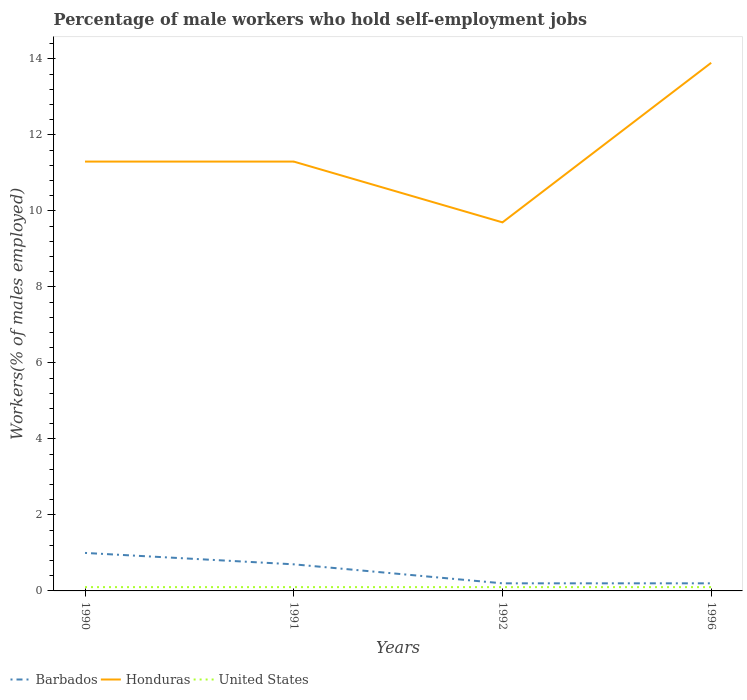How many different coloured lines are there?
Your response must be concise. 3. Does the line corresponding to Honduras intersect with the line corresponding to Barbados?
Provide a short and direct response. No. Is the number of lines equal to the number of legend labels?
Offer a very short reply. Yes. Across all years, what is the maximum percentage of self-employed male workers in United States?
Offer a very short reply. 0.1. In which year was the percentage of self-employed male workers in Honduras maximum?
Your response must be concise. 1992. What is the total percentage of self-employed male workers in Honduras in the graph?
Your response must be concise. -2.6. What is the difference between the highest and the second highest percentage of self-employed male workers in Barbados?
Provide a short and direct response. 0.8. Is the percentage of self-employed male workers in Honduras strictly greater than the percentage of self-employed male workers in United States over the years?
Make the answer very short. No. How many years are there in the graph?
Provide a short and direct response. 4. Does the graph contain grids?
Your answer should be compact. No. Where does the legend appear in the graph?
Give a very brief answer. Bottom left. How many legend labels are there?
Offer a terse response. 3. What is the title of the graph?
Ensure brevity in your answer.  Percentage of male workers who hold self-employment jobs. Does "Austria" appear as one of the legend labels in the graph?
Provide a short and direct response. No. What is the label or title of the Y-axis?
Offer a very short reply. Workers(% of males employed). What is the Workers(% of males employed) of Barbados in 1990?
Your answer should be very brief. 1. What is the Workers(% of males employed) in Honduras in 1990?
Keep it short and to the point. 11.3. What is the Workers(% of males employed) of United States in 1990?
Provide a short and direct response. 0.1. What is the Workers(% of males employed) of Barbados in 1991?
Offer a terse response. 0.7. What is the Workers(% of males employed) in Honduras in 1991?
Your answer should be very brief. 11.3. What is the Workers(% of males employed) of United States in 1991?
Your response must be concise. 0.1. What is the Workers(% of males employed) of Barbados in 1992?
Offer a very short reply. 0.2. What is the Workers(% of males employed) in Honduras in 1992?
Provide a short and direct response. 9.7. What is the Workers(% of males employed) in United States in 1992?
Offer a very short reply. 0.1. What is the Workers(% of males employed) in Barbados in 1996?
Provide a succinct answer. 0.2. What is the Workers(% of males employed) of Honduras in 1996?
Provide a short and direct response. 13.9. What is the Workers(% of males employed) of United States in 1996?
Keep it short and to the point. 0.1. Across all years, what is the maximum Workers(% of males employed) of Honduras?
Provide a succinct answer. 13.9. Across all years, what is the maximum Workers(% of males employed) of United States?
Your answer should be compact. 0.1. Across all years, what is the minimum Workers(% of males employed) in Barbados?
Offer a very short reply. 0.2. Across all years, what is the minimum Workers(% of males employed) of Honduras?
Your answer should be very brief. 9.7. Across all years, what is the minimum Workers(% of males employed) in United States?
Offer a terse response. 0.1. What is the total Workers(% of males employed) in Barbados in the graph?
Offer a very short reply. 2.1. What is the total Workers(% of males employed) in Honduras in the graph?
Your answer should be compact. 46.2. What is the total Workers(% of males employed) of United States in the graph?
Offer a very short reply. 0.4. What is the difference between the Workers(% of males employed) of Honduras in 1990 and that in 1992?
Keep it short and to the point. 1.6. What is the difference between the Workers(% of males employed) in United States in 1990 and that in 1992?
Offer a terse response. 0. What is the difference between the Workers(% of males employed) in Barbados in 1990 and that in 1996?
Give a very brief answer. 0.8. What is the difference between the Workers(% of males employed) of Honduras in 1990 and that in 1996?
Your response must be concise. -2.6. What is the difference between the Workers(% of males employed) in United States in 1990 and that in 1996?
Keep it short and to the point. 0. What is the difference between the Workers(% of males employed) of United States in 1991 and that in 1992?
Offer a terse response. 0. What is the difference between the Workers(% of males employed) of United States in 1991 and that in 1996?
Your answer should be very brief. 0. What is the difference between the Workers(% of males employed) in Honduras in 1992 and that in 1996?
Make the answer very short. -4.2. What is the difference between the Workers(% of males employed) of United States in 1992 and that in 1996?
Offer a terse response. 0. What is the difference between the Workers(% of males employed) of Barbados in 1990 and the Workers(% of males employed) of United States in 1991?
Your answer should be compact. 0.9. What is the difference between the Workers(% of males employed) of Barbados in 1990 and the Workers(% of males employed) of United States in 1992?
Provide a succinct answer. 0.9. What is the difference between the Workers(% of males employed) in Barbados in 1991 and the Workers(% of males employed) in Honduras in 1992?
Ensure brevity in your answer.  -9. What is the difference between the Workers(% of males employed) in Barbados in 1991 and the Workers(% of males employed) in Honduras in 1996?
Make the answer very short. -13.2. What is the difference between the Workers(% of males employed) in Barbados in 1991 and the Workers(% of males employed) in United States in 1996?
Offer a terse response. 0.6. What is the difference between the Workers(% of males employed) of Honduras in 1991 and the Workers(% of males employed) of United States in 1996?
Offer a terse response. 11.2. What is the difference between the Workers(% of males employed) in Barbados in 1992 and the Workers(% of males employed) in Honduras in 1996?
Provide a short and direct response. -13.7. What is the average Workers(% of males employed) in Barbados per year?
Your response must be concise. 0.53. What is the average Workers(% of males employed) in Honduras per year?
Keep it short and to the point. 11.55. In the year 1990, what is the difference between the Workers(% of males employed) of Barbados and Workers(% of males employed) of Honduras?
Your answer should be very brief. -10.3. In the year 1990, what is the difference between the Workers(% of males employed) in Honduras and Workers(% of males employed) in United States?
Your answer should be very brief. 11.2. In the year 1991, what is the difference between the Workers(% of males employed) in Barbados and Workers(% of males employed) in United States?
Keep it short and to the point. 0.6. In the year 1991, what is the difference between the Workers(% of males employed) of Honduras and Workers(% of males employed) of United States?
Offer a terse response. 11.2. In the year 1992, what is the difference between the Workers(% of males employed) in Barbados and Workers(% of males employed) in Honduras?
Give a very brief answer. -9.5. In the year 1996, what is the difference between the Workers(% of males employed) in Barbados and Workers(% of males employed) in Honduras?
Ensure brevity in your answer.  -13.7. What is the ratio of the Workers(% of males employed) of Barbados in 1990 to that in 1991?
Your answer should be compact. 1.43. What is the ratio of the Workers(% of males employed) of Barbados in 1990 to that in 1992?
Give a very brief answer. 5. What is the ratio of the Workers(% of males employed) in Honduras in 1990 to that in 1992?
Offer a terse response. 1.16. What is the ratio of the Workers(% of males employed) of United States in 1990 to that in 1992?
Offer a very short reply. 1. What is the ratio of the Workers(% of males employed) in Honduras in 1990 to that in 1996?
Provide a succinct answer. 0.81. What is the ratio of the Workers(% of males employed) of Honduras in 1991 to that in 1992?
Keep it short and to the point. 1.16. What is the ratio of the Workers(% of males employed) in Honduras in 1991 to that in 1996?
Offer a terse response. 0.81. What is the ratio of the Workers(% of males employed) in United States in 1991 to that in 1996?
Provide a succinct answer. 1. What is the ratio of the Workers(% of males employed) of Honduras in 1992 to that in 1996?
Your answer should be very brief. 0.7. What is the difference between the highest and the second highest Workers(% of males employed) of Barbados?
Keep it short and to the point. 0.3. What is the difference between the highest and the lowest Workers(% of males employed) of United States?
Offer a very short reply. 0. 